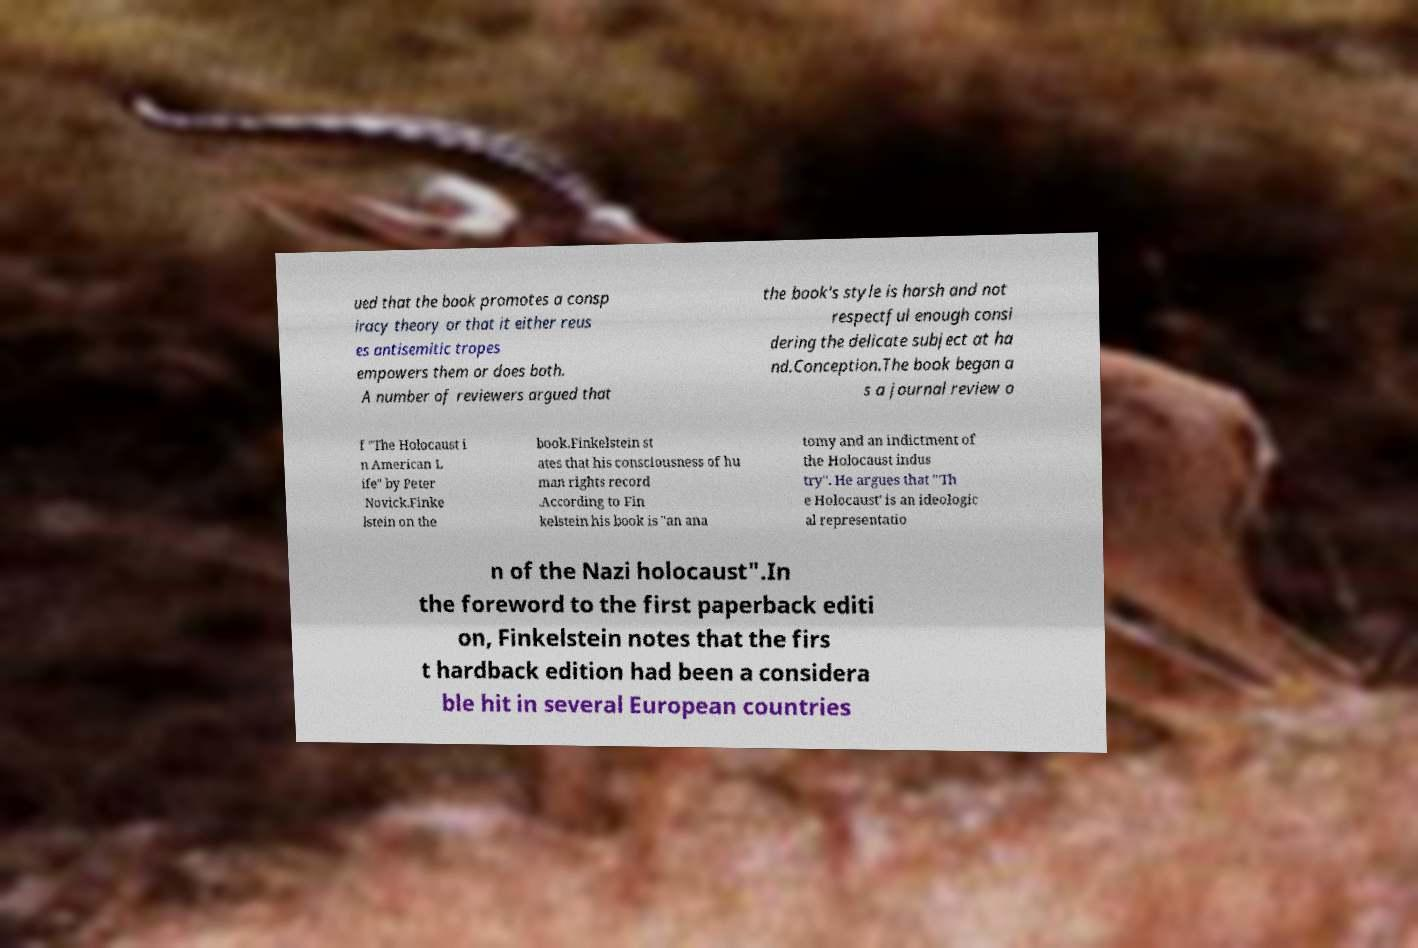Could you extract and type out the text from this image? ued that the book promotes a consp iracy theory or that it either reus es antisemitic tropes empowers them or does both. A number of reviewers argued that the book's style is harsh and not respectful enough consi dering the delicate subject at ha nd.Conception.The book began a s a journal review o f "The Holocaust i n American L ife" by Peter Novick.Finke lstein on the book.Finkelstein st ates that his consciousness of hu man rights record .According to Fin kelstein his book is "an ana tomy and an indictment of the Holocaust indus try". He argues that "'Th e Holocaust' is an ideologic al representatio n of the Nazi holocaust".In the foreword to the first paperback editi on, Finkelstein notes that the firs t hardback edition had been a considera ble hit in several European countries 